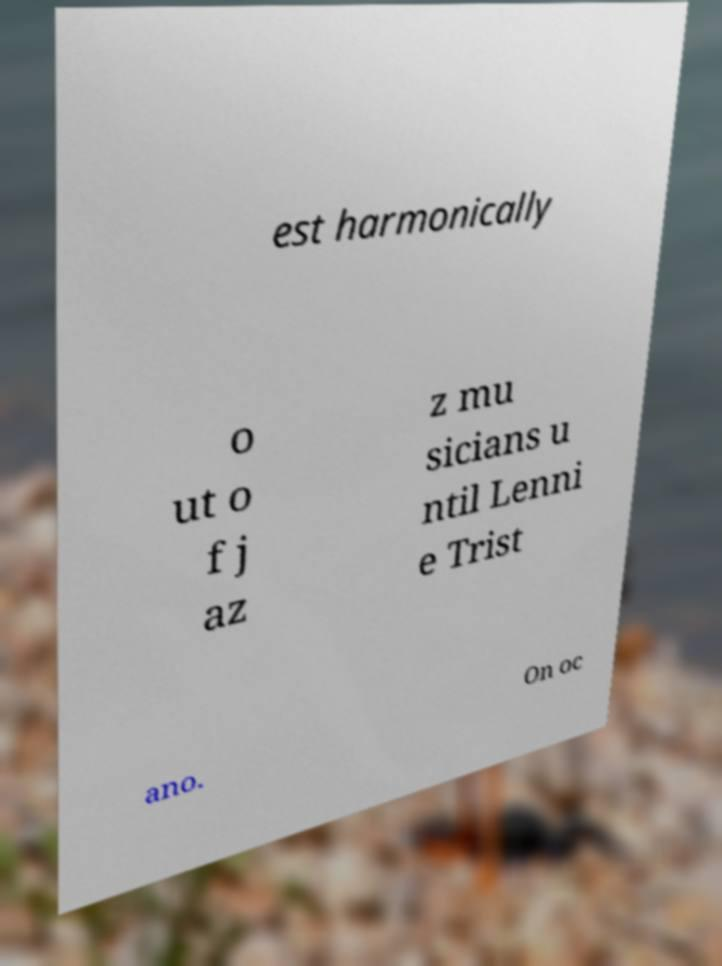Please read and relay the text visible in this image. What does it say? est harmonically o ut o f j az z mu sicians u ntil Lenni e Trist ano. On oc 